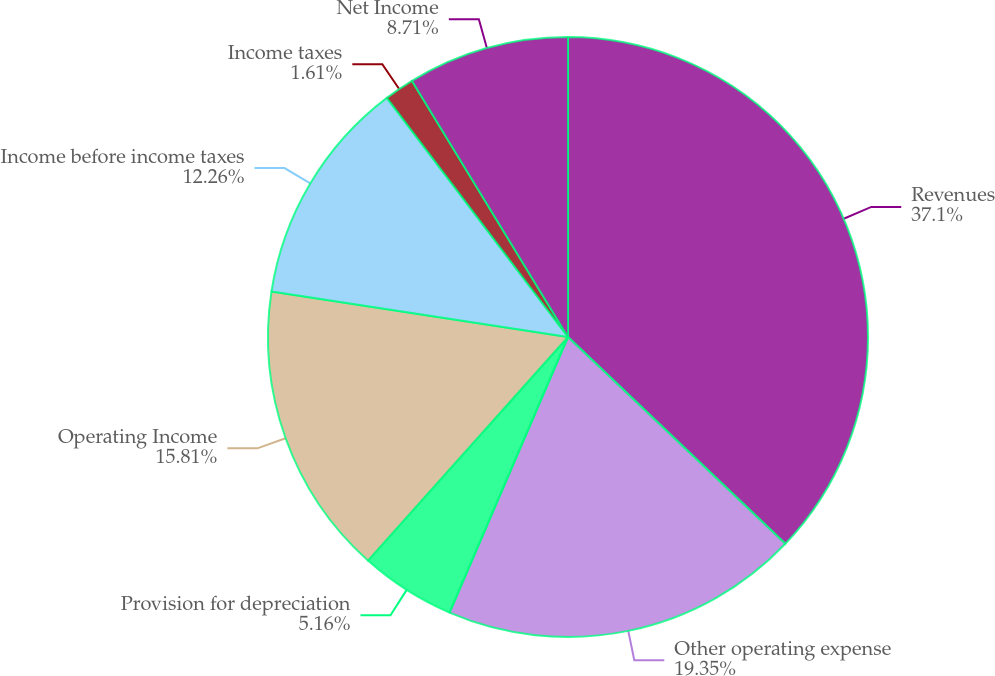Convert chart. <chart><loc_0><loc_0><loc_500><loc_500><pie_chart><fcel>Revenues<fcel>Other operating expense<fcel>Provision for depreciation<fcel>Operating Income<fcel>Income before income taxes<fcel>Income taxes<fcel>Net Income<nl><fcel>37.11%<fcel>19.36%<fcel>5.16%<fcel>15.81%<fcel>12.26%<fcel>1.61%<fcel>8.71%<nl></chart> 